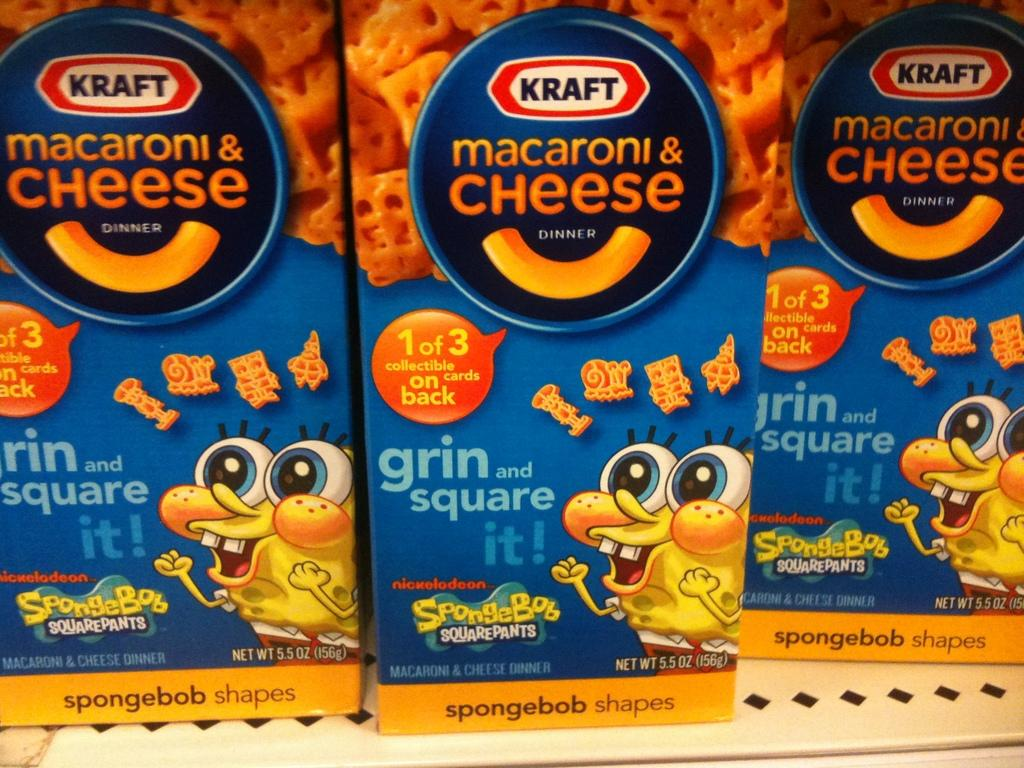How many cheese boxes are present in the image? There are three cheese boxes in the image. What is depicted on the cheese boxes? There are depictions on the cheese boxes. Who is the expert on the cheese boxes in the image? There is no expert mentioned or depicted on the cheese boxes in the image. What type of flag is visible on the cheese boxes in the image? There is no flag visible on the cheese boxes in the image. 